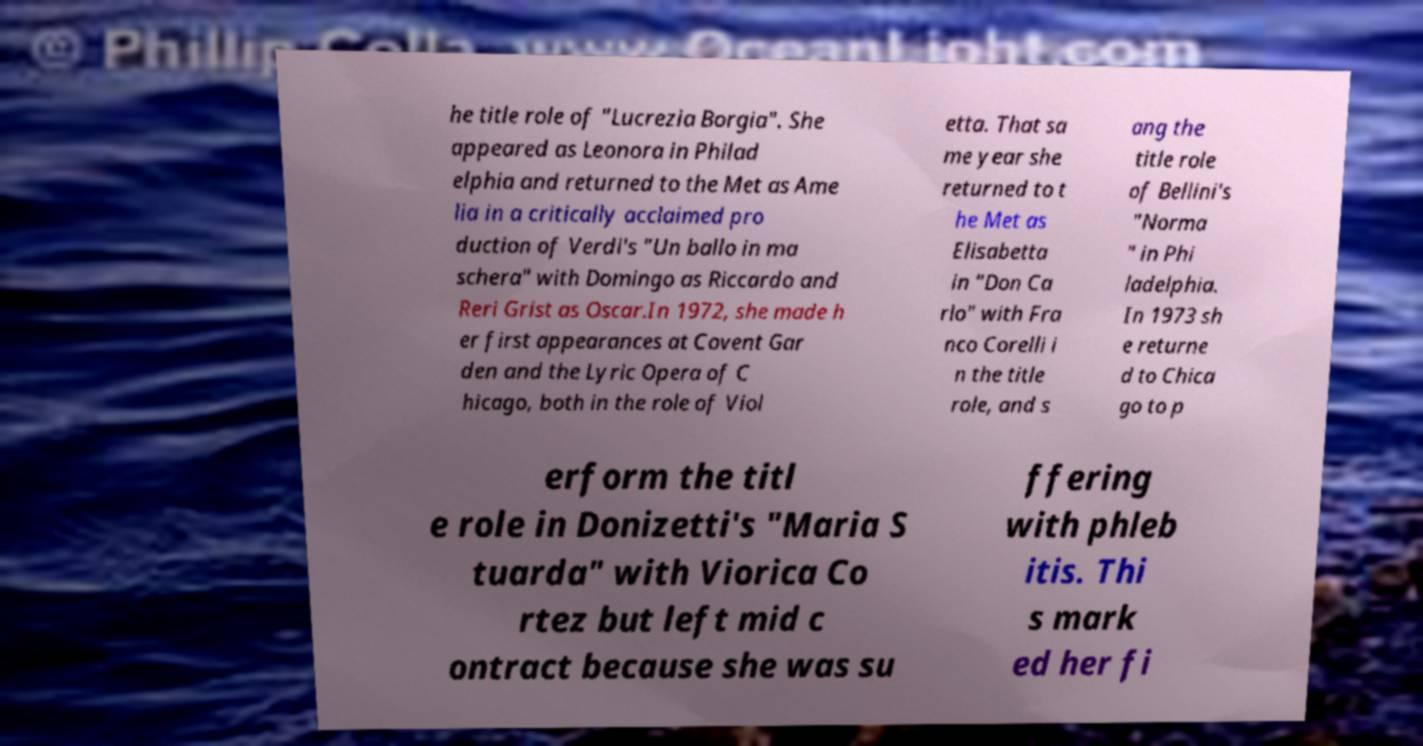Could you extract and type out the text from this image? he title role of "Lucrezia Borgia". She appeared as Leonora in Philad elphia and returned to the Met as Ame lia in a critically acclaimed pro duction of Verdi's "Un ballo in ma schera" with Domingo as Riccardo and Reri Grist as Oscar.In 1972, she made h er first appearances at Covent Gar den and the Lyric Opera of C hicago, both in the role of Viol etta. That sa me year she returned to t he Met as Elisabetta in "Don Ca rlo" with Fra nco Corelli i n the title role, and s ang the title role of Bellini's "Norma " in Phi ladelphia. In 1973 sh e returne d to Chica go to p erform the titl e role in Donizetti's "Maria S tuarda" with Viorica Co rtez but left mid c ontract because she was su ffering with phleb itis. Thi s mark ed her fi 